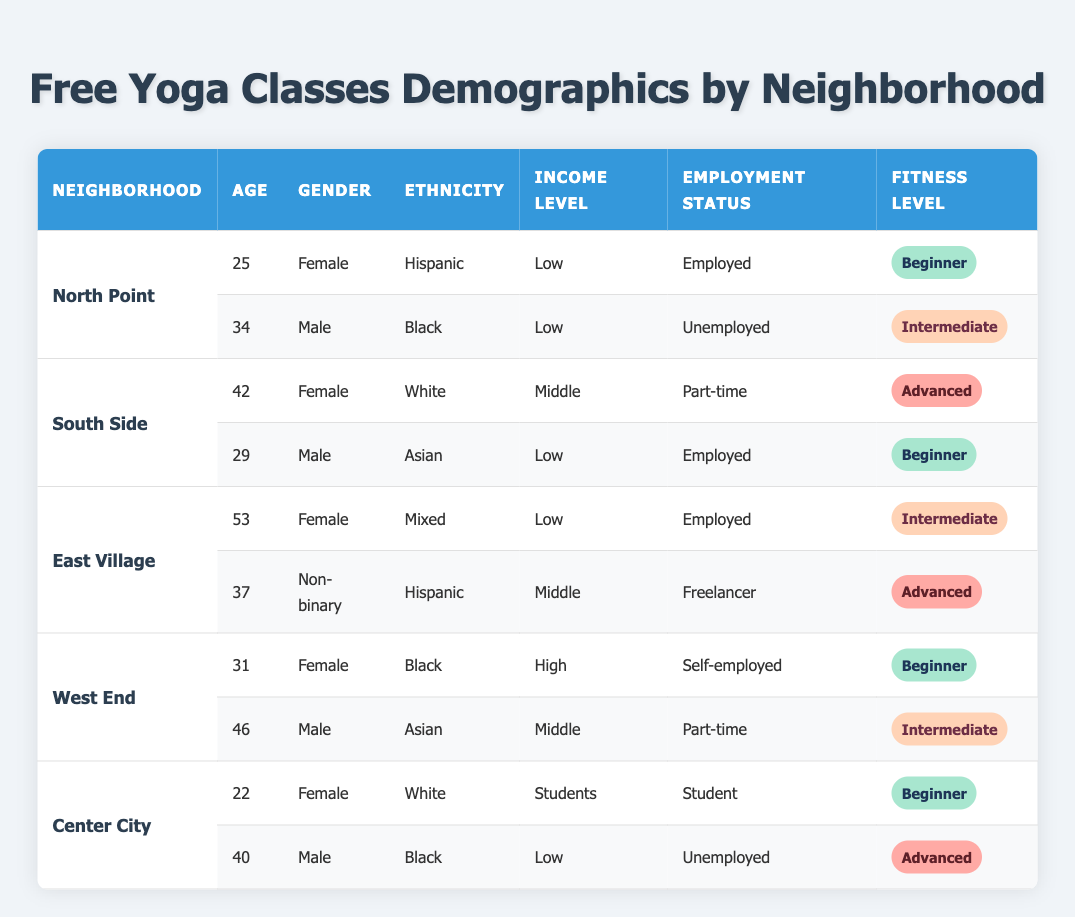What is the total number of participants in North Point? The neighborhood North Point has two participants listed in the table. Therefore, the total number of participants in North Point is 2.
Answer: 2 What is the income level of the male participant from South Side? In the South Side section, the male participant is listed with an income level of "Low."
Answer: Low Which neighborhood has the highest age participant? The highest age participant is 53 years old from East Village. I reviewed the ages listed for each neighborhood and compared them. East Village has the oldest participant.
Answer: East Village Is there a non-binary participant in the classes? Yes, there is a non-binary participant, who is 37 years old and from the East Village. I found this by scanning through all the gender entries in the table.
Answer: Yes What is the average age of participants from West End? The West End neighborhood has two participants with ages 31 and 46. To find the average age: (31 + 46) / 2 = 77 / 2 = 38.5. So, the average age of participants from West End is 38.5.
Answer: 38.5 How many participants in total identify as Female across all neighborhoods? In the table, I counted the female participants from all neighborhoods. The participants from North Point (1), South Side (1), East Village (1), West End (1), and Center City (1) total to 5 females.
Answer: 5 What are the employment statuses of all participants from East Village? The participants from East Village are 53 years old and "Employed," and the other is 37 years old and "Freelancer." I gathered this information by looking through the employment status column for East Village.
Answer: Employed, Freelancer Which neighborhood has both participants classified as "Beginner"? North Point has one participant classified as "Beginner" (age 25, female), and West End has one participant classified as "Beginner" (age 31, female). However, only West End includes another participant classified as "Intermediate." Therefore, both "Beginner" participants are found in North Point while only part of West End has "Beginner." Thus, it cannot be just one neighborhood with both as "Beginner."
Answer: North Point How many participants from Center City are unemployed? There are two participants from Center City, and one of them is unemployed (age 40, male). I confirmed this by reading through the employment status information for both participants in Center City.
Answer: 1 